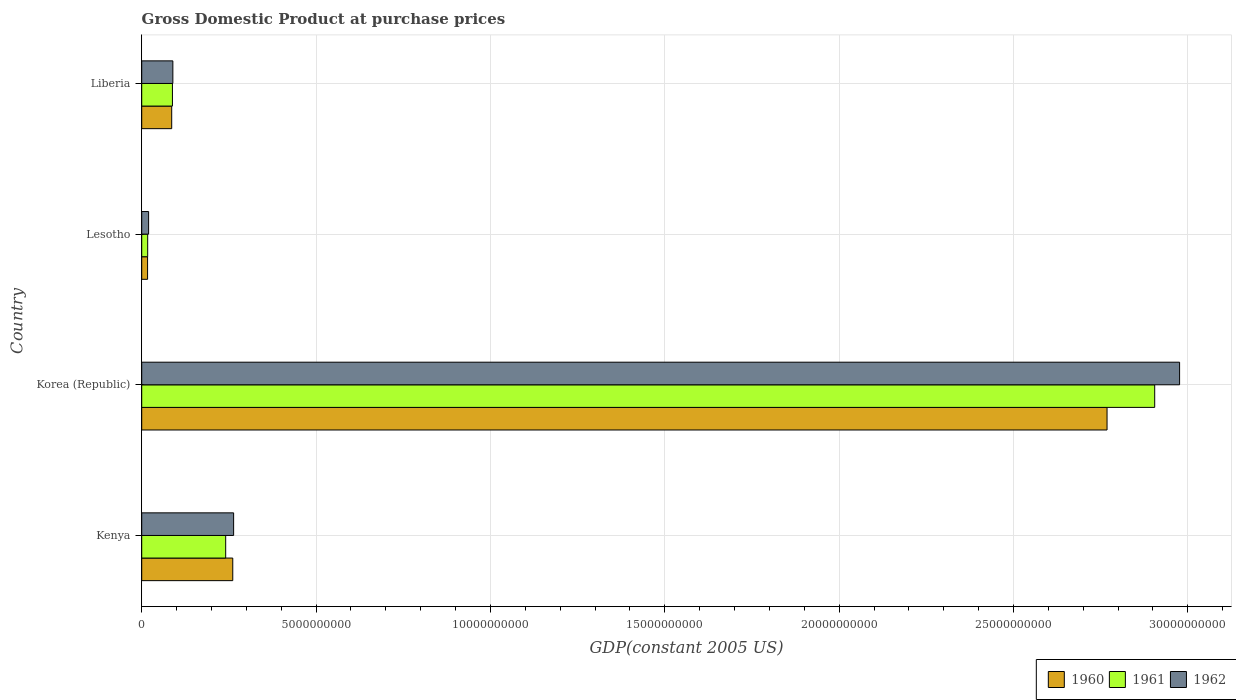How many different coloured bars are there?
Offer a very short reply. 3. Are the number of bars on each tick of the Y-axis equal?
Make the answer very short. Yes. How many bars are there on the 1st tick from the top?
Your response must be concise. 3. How many bars are there on the 1st tick from the bottom?
Keep it short and to the point. 3. What is the label of the 2nd group of bars from the top?
Your response must be concise. Lesotho. What is the GDP at purchase prices in 1960 in Kenya?
Provide a short and direct response. 2.61e+09. Across all countries, what is the maximum GDP at purchase prices in 1962?
Your answer should be compact. 2.98e+1. Across all countries, what is the minimum GDP at purchase prices in 1960?
Offer a very short reply. 1.68e+08. In which country was the GDP at purchase prices in 1960 maximum?
Your answer should be compact. Korea (Republic). In which country was the GDP at purchase prices in 1961 minimum?
Ensure brevity in your answer.  Lesotho. What is the total GDP at purchase prices in 1962 in the graph?
Offer a terse response. 3.35e+1. What is the difference between the GDP at purchase prices in 1961 in Korea (Republic) and that in Lesotho?
Offer a terse response. 2.89e+1. What is the difference between the GDP at purchase prices in 1962 in Liberia and the GDP at purchase prices in 1961 in Kenya?
Provide a short and direct response. -1.52e+09. What is the average GDP at purchase prices in 1960 per country?
Provide a short and direct response. 7.83e+09. What is the difference between the GDP at purchase prices in 1960 and GDP at purchase prices in 1961 in Korea (Republic)?
Provide a short and direct response. -1.37e+09. In how many countries, is the GDP at purchase prices in 1962 greater than 8000000000 US$?
Your answer should be very brief. 1. What is the ratio of the GDP at purchase prices in 1962 in Korea (Republic) to that in Liberia?
Make the answer very short. 33.34. Is the difference between the GDP at purchase prices in 1960 in Kenya and Korea (Republic) greater than the difference between the GDP at purchase prices in 1961 in Kenya and Korea (Republic)?
Your answer should be very brief. Yes. What is the difference between the highest and the second highest GDP at purchase prices in 1960?
Offer a very short reply. 2.51e+1. What is the difference between the highest and the lowest GDP at purchase prices in 1960?
Offer a terse response. 2.75e+1. In how many countries, is the GDP at purchase prices in 1961 greater than the average GDP at purchase prices in 1961 taken over all countries?
Your answer should be compact. 1. What does the 1st bar from the bottom in Korea (Republic) represents?
Offer a terse response. 1960. Is it the case that in every country, the sum of the GDP at purchase prices in 1961 and GDP at purchase prices in 1962 is greater than the GDP at purchase prices in 1960?
Your answer should be compact. Yes. How many bars are there?
Provide a short and direct response. 12. Are the values on the major ticks of X-axis written in scientific E-notation?
Your answer should be very brief. No. Does the graph contain any zero values?
Offer a very short reply. No. How are the legend labels stacked?
Offer a terse response. Horizontal. What is the title of the graph?
Your response must be concise. Gross Domestic Product at purchase prices. What is the label or title of the X-axis?
Provide a succinct answer. GDP(constant 2005 US). What is the GDP(constant 2005 US) of 1960 in Kenya?
Your response must be concise. 2.61e+09. What is the GDP(constant 2005 US) of 1961 in Kenya?
Keep it short and to the point. 2.41e+09. What is the GDP(constant 2005 US) of 1962 in Kenya?
Keep it short and to the point. 2.64e+09. What is the GDP(constant 2005 US) of 1960 in Korea (Republic)?
Your answer should be very brief. 2.77e+1. What is the GDP(constant 2005 US) of 1961 in Korea (Republic)?
Offer a very short reply. 2.90e+1. What is the GDP(constant 2005 US) of 1962 in Korea (Republic)?
Make the answer very short. 2.98e+1. What is the GDP(constant 2005 US) in 1960 in Lesotho?
Your answer should be very brief. 1.68e+08. What is the GDP(constant 2005 US) in 1961 in Lesotho?
Ensure brevity in your answer.  1.71e+08. What is the GDP(constant 2005 US) in 1962 in Lesotho?
Your answer should be compact. 1.97e+08. What is the GDP(constant 2005 US) in 1960 in Liberia?
Keep it short and to the point. 8.60e+08. What is the GDP(constant 2005 US) of 1961 in Liberia?
Ensure brevity in your answer.  8.81e+08. What is the GDP(constant 2005 US) in 1962 in Liberia?
Keep it short and to the point. 8.93e+08. Across all countries, what is the maximum GDP(constant 2005 US) of 1960?
Your response must be concise. 2.77e+1. Across all countries, what is the maximum GDP(constant 2005 US) of 1961?
Provide a succinct answer. 2.90e+1. Across all countries, what is the maximum GDP(constant 2005 US) in 1962?
Provide a succinct answer. 2.98e+1. Across all countries, what is the minimum GDP(constant 2005 US) of 1960?
Make the answer very short. 1.68e+08. Across all countries, what is the minimum GDP(constant 2005 US) of 1961?
Provide a succinct answer. 1.71e+08. Across all countries, what is the minimum GDP(constant 2005 US) in 1962?
Your response must be concise. 1.97e+08. What is the total GDP(constant 2005 US) of 1960 in the graph?
Ensure brevity in your answer.  3.13e+1. What is the total GDP(constant 2005 US) in 1961 in the graph?
Your answer should be compact. 3.25e+1. What is the total GDP(constant 2005 US) in 1962 in the graph?
Offer a very short reply. 3.35e+1. What is the difference between the GDP(constant 2005 US) in 1960 in Kenya and that in Korea (Republic)?
Keep it short and to the point. -2.51e+1. What is the difference between the GDP(constant 2005 US) of 1961 in Kenya and that in Korea (Republic)?
Keep it short and to the point. -2.66e+1. What is the difference between the GDP(constant 2005 US) of 1962 in Kenya and that in Korea (Republic)?
Ensure brevity in your answer.  -2.71e+1. What is the difference between the GDP(constant 2005 US) in 1960 in Kenya and that in Lesotho?
Provide a short and direct response. 2.44e+09. What is the difference between the GDP(constant 2005 US) of 1961 in Kenya and that in Lesotho?
Make the answer very short. 2.24e+09. What is the difference between the GDP(constant 2005 US) in 1962 in Kenya and that in Lesotho?
Make the answer very short. 2.44e+09. What is the difference between the GDP(constant 2005 US) of 1960 in Kenya and that in Liberia?
Offer a very short reply. 1.75e+09. What is the difference between the GDP(constant 2005 US) in 1961 in Kenya and that in Liberia?
Make the answer very short. 1.53e+09. What is the difference between the GDP(constant 2005 US) in 1962 in Kenya and that in Liberia?
Ensure brevity in your answer.  1.74e+09. What is the difference between the GDP(constant 2005 US) of 1960 in Korea (Republic) and that in Lesotho?
Your response must be concise. 2.75e+1. What is the difference between the GDP(constant 2005 US) of 1961 in Korea (Republic) and that in Lesotho?
Keep it short and to the point. 2.89e+1. What is the difference between the GDP(constant 2005 US) in 1962 in Korea (Republic) and that in Lesotho?
Offer a terse response. 2.96e+1. What is the difference between the GDP(constant 2005 US) in 1960 in Korea (Republic) and that in Liberia?
Your answer should be very brief. 2.68e+1. What is the difference between the GDP(constant 2005 US) of 1961 in Korea (Republic) and that in Liberia?
Your answer should be compact. 2.82e+1. What is the difference between the GDP(constant 2005 US) in 1962 in Korea (Republic) and that in Liberia?
Make the answer very short. 2.89e+1. What is the difference between the GDP(constant 2005 US) in 1960 in Lesotho and that in Liberia?
Keep it short and to the point. -6.92e+08. What is the difference between the GDP(constant 2005 US) of 1961 in Lesotho and that in Liberia?
Provide a short and direct response. -7.10e+08. What is the difference between the GDP(constant 2005 US) of 1962 in Lesotho and that in Liberia?
Keep it short and to the point. -6.95e+08. What is the difference between the GDP(constant 2005 US) of 1960 in Kenya and the GDP(constant 2005 US) of 1961 in Korea (Republic)?
Offer a very short reply. -2.64e+1. What is the difference between the GDP(constant 2005 US) of 1960 in Kenya and the GDP(constant 2005 US) of 1962 in Korea (Republic)?
Your answer should be compact. -2.72e+1. What is the difference between the GDP(constant 2005 US) in 1961 in Kenya and the GDP(constant 2005 US) in 1962 in Korea (Republic)?
Offer a very short reply. -2.74e+1. What is the difference between the GDP(constant 2005 US) of 1960 in Kenya and the GDP(constant 2005 US) of 1961 in Lesotho?
Provide a short and direct response. 2.44e+09. What is the difference between the GDP(constant 2005 US) of 1960 in Kenya and the GDP(constant 2005 US) of 1962 in Lesotho?
Your answer should be very brief. 2.41e+09. What is the difference between the GDP(constant 2005 US) of 1961 in Kenya and the GDP(constant 2005 US) of 1962 in Lesotho?
Your answer should be compact. 2.21e+09. What is the difference between the GDP(constant 2005 US) of 1960 in Kenya and the GDP(constant 2005 US) of 1961 in Liberia?
Your answer should be compact. 1.73e+09. What is the difference between the GDP(constant 2005 US) of 1960 in Kenya and the GDP(constant 2005 US) of 1962 in Liberia?
Give a very brief answer. 1.72e+09. What is the difference between the GDP(constant 2005 US) of 1961 in Kenya and the GDP(constant 2005 US) of 1962 in Liberia?
Keep it short and to the point. 1.52e+09. What is the difference between the GDP(constant 2005 US) in 1960 in Korea (Republic) and the GDP(constant 2005 US) in 1961 in Lesotho?
Your response must be concise. 2.75e+1. What is the difference between the GDP(constant 2005 US) in 1960 in Korea (Republic) and the GDP(constant 2005 US) in 1962 in Lesotho?
Give a very brief answer. 2.75e+1. What is the difference between the GDP(constant 2005 US) of 1961 in Korea (Republic) and the GDP(constant 2005 US) of 1962 in Lesotho?
Your response must be concise. 2.89e+1. What is the difference between the GDP(constant 2005 US) in 1960 in Korea (Republic) and the GDP(constant 2005 US) in 1961 in Liberia?
Your response must be concise. 2.68e+1. What is the difference between the GDP(constant 2005 US) in 1960 in Korea (Republic) and the GDP(constant 2005 US) in 1962 in Liberia?
Keep it short and to the point. 2.68e+1. What is the difference between the GDP(constant 2005 US) of 1961 in Korea (Republic) and the GDP(constant 2005 US) of 1962 in Liberia?
Give a very brief answer. 2.82e+1. What is the difference between the GDP(constant 2005 US) in 1960 in Lesotho and the GDP(constant 2005 US) in 1961 in Liberia?
Make the answer very short. -7.13e+08. What is the difference between the GDP(constant 2005 US) of 1960 in Lesotho and the GDP(constant 2005 US) of 1962 in Liberia?
Ensure brevity in your answer.  -7.25e+08. What is the difference between the GDP(constant 2005 US) of 1961 in Lesotho and the GDP(constant 2005 US) of 1962 in Liberia?
Give a very brief answer. -7.22e+08. What is the average GDP(constant 2005 US) in 1960 per country?
Ensure brevity in your answer.  7.83e+09. What is the average GDP(constant 2005 US) of 1961 per country?
Give a very brief answer. 8.13e+09. What is the average GDP(constant 2005 US) in 1962 per country?
Your answer should be compact. 8.37e+09. What is the difference between the GDP(constant 2005 US) of 1960 and GDP(constant 2005 US) of 1961 in Kenya?
Your answer should be very brief. 2.03e+08. What is the difference between the GDP(constant 2005 US) of 1960 and GDP(constant 2005 US) of 1962 in Kenya?
Your answer should be very brief. -2.47e+07. What is the difference between the GDP(constant 2005 US) in 1961 and GDP(constant 2005 US) in 1962 in Kenya?
Give a very brief answer. -2.28e+08. What is the difference between the GDP(constant 2005 US) of 1960 and GDP(constant 2005 US) of 1961 in Korea (Republic)?
Give a very brief answer. -1.37e+09. What is the difference between the GDP(constant 2005 US) of 1960 and GDP(constant 2005 US) of 1962 in Korea (Republic)?
Provide a short and direct response. -2.08e+09. What is the difference between the GDP(constant 2005 US) of 1961 and GDP(constant 2005 US) of 1962 in Korea (Republic)?
Keep it short and to the point. -7.14e+08. What is the difference between the GDP(constant 2005 US) in 1960 and GDP(constant 2005 US) in 1961 in Lesotho?
Your answer should be very brief. -3.13e+06. What is the difference between the GDP(constant 2005 US) in 1960 and GDP(constant 2005 US) in 1962 in Lesotho?
Make the answer very short. -2.94e+07. What is the difference between the GDP(constant 2005 US) in 1961 and GDP(constant 2005 US) in 1962 in Lesotho?
Provide a succinct answer. -2.62e+07. What is the difference between the GDP(constant 2005 US) in 1960 and GDP(constant 2005 US) in 1961 in Liberia?
Keep it short and to the point. -2.10e+07. What is the difference between the GDP(constant 2005 US) in 1960 and GDP(constant 2005 US) in 1962 in Liberia?
Make the answer very short. -3.28e+07. What is the difference between the GDP(constant 2005 US) in 1961 and GDP(constant 2005 US) in 1962 in Liberia?
Provide a short and direct response. -1.18e+07. What is the ratio of the GDP(constant 2005 US) of 1960 in Kenya to that in Korea (Republic)?
Offer a very short reply. 0.09. What is the ratio of the GDP(constant 2005 US) in 1961 in Kenya to that in Korea (Republic)?
Offer a very short reply. 0.08. What is the ratio of the GDP(constant 2005 US) of 1962 in Kenya to that in Korea (Republic)?
Ensure brevity in your answer.  0.09. What is the ratio of the GDP(constant 2005 US) of 1960 in Kenya to that in Lesotho?
Make the answer very short. 15.54. What is the ratio of the GDP(constant 2005 US) of 1961 in Kenya to that in Lesotho?
Offer a terse response. 14.07. What is the ratio of the GDP(constant 2005 US) in 1962 in Kenya to that in Lesotho?
Your answer should be compact. 13.35. What is the ratio of the GDP(constant 2005 US) of 1960 in Kenya to that in Liberia?
Your answer should be compact. 3.04. What is the ratio of the GDP(constant 2005 US) in 1961 in Kenya to that in Liberia?
Your answer should be compact. 2.73. What is the ratio of the GDP(constant 2005 US) in 1962 in Kenya to that in Liberia?
Provide a succinct answer. 2.95. What is the ratio of the GDP(constant 2005 US) of 1960 in Korea (Republic) to that in Lesotho?
Offer a very short reply. 164.73. What is the ratio of the GDP(constant 2005 US) in 1961 in Korea (Republic) to that in Lesotho?
Offer a terse response. 169.7. What is the ratio of the GDP(constant 2005 US) of 1962 in Korea (Republic) to that in Lesotho?
Keep it short and to the point. 150.76. What is the ratio of the GDP(constant 2005 US) in 1960 in Korea (Republic) to that in Liberia?
Provide a succinct answer. 32.19. What is the ratio of the GDP(constant 2005 US) of 1961 in Korea (Republic) to that in Liberia?
Your answer should be very brief. 32.98. What is the ratio of the GDP(constant 2005 US) in 1962 in Korea (Republic) to that in Liberia?
Make the answer very short. 33.34. What is the ratio of the GDP(constant 2005 US) of 1960 in Lesotho to that in Liberia?
Make the answer very short. 0.2. What is the ratio of the GDP(constant 2005 US) in 1961 in Lesotho to that in Liberia?
Your answer should be compact. 0.19. What is the ratio of the GDP(constant 2005 US) of 1962 in Lesotho to that in Liberia?
Ensure brevity in your answer.  0.22. What is the difference between the highest and the second highest GDP(constant 2005 US) of 1960?
Offer a terse response. 2.51e+1. What is the difference between the highest and the second highest GDP(constant 2005 US) in 1961?
Provide a succinct answer. 2.66e+1. What is the difference between the highest and the second highest GDP(constant 2005 US) in 1962?
Give a very brief answer. 2.71e+1. What is the difference between the highest and the lowest GDP(constant 2005 US) in 1960?
Make the answer very short. 2.75e+1. What is the difference between the highest and the lowest GDP(constant 2005 US) of 1961?
Your answer should be compact. 2.89e+1. What is the difference between the highest and the lowest GDP(constant 2005 US) in 1962?
Make the answer very short. 2.96e+1. 